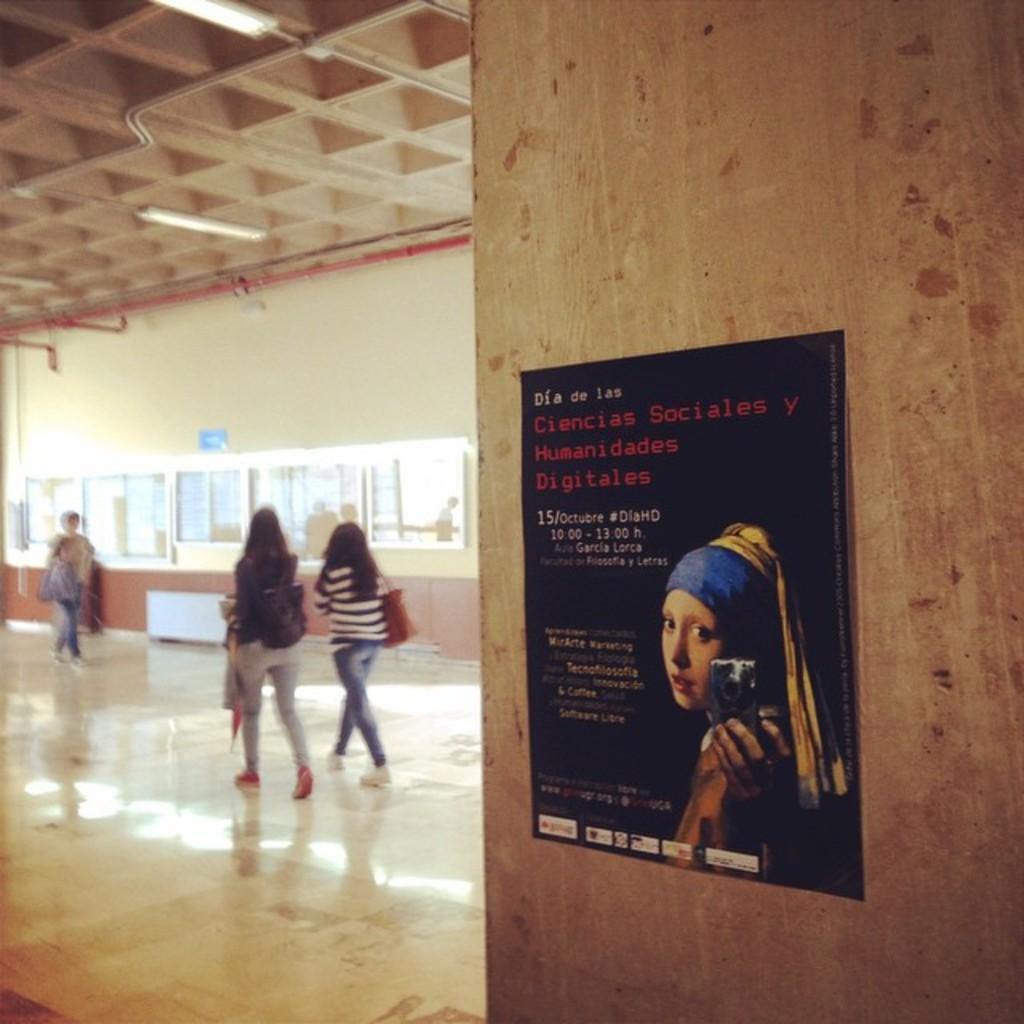What are the people in the image doing? The people in the image are walking. On what surface are the people walking? The people are walking on the floor. What can be seen on the wall in the image? There is a poster on the wall in the image. What type of coal is being used by the servant in the image? There is no servant or coal present in the image. What rule is being enforced by the people walking in the image? There is no rule being enforced in the image; the people are simply walking. 